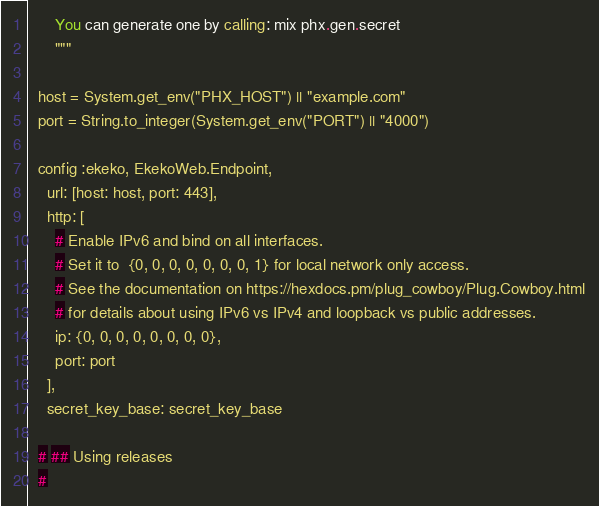Convert code to text. <code><loc_0><loc_0><loc_500><loc_500><_Elixir_>      You can generate one by calling: mix phx.gen.secret
      """

  host = System.get_env("PHX_HOST") || "example.com"
  port = String.to_integer(System.get_env("PORT") || "4000")

  config :ekeko, EkekoWeb.Endpoint,
    url: [host: host, port: 443],
    http: [
      # Enable IPv6 and bind on all interfaces.
      # Set it to  {0, 0, 0, 0, 0, 0, 0, 1} for local network only access.
      # See the documentation on https://hexdocs.pm/plug_cowboy/Plug.Cowboy.html
      # for details about using IPv6 vs IPv4 and loopback vs public addresses.
      ip: {0, 0, 0, 0, 0, 0, 0, 0},
      port: port
    ],
    secret_key_base: secret_key_base

  # ## Using releases
  #</code> 